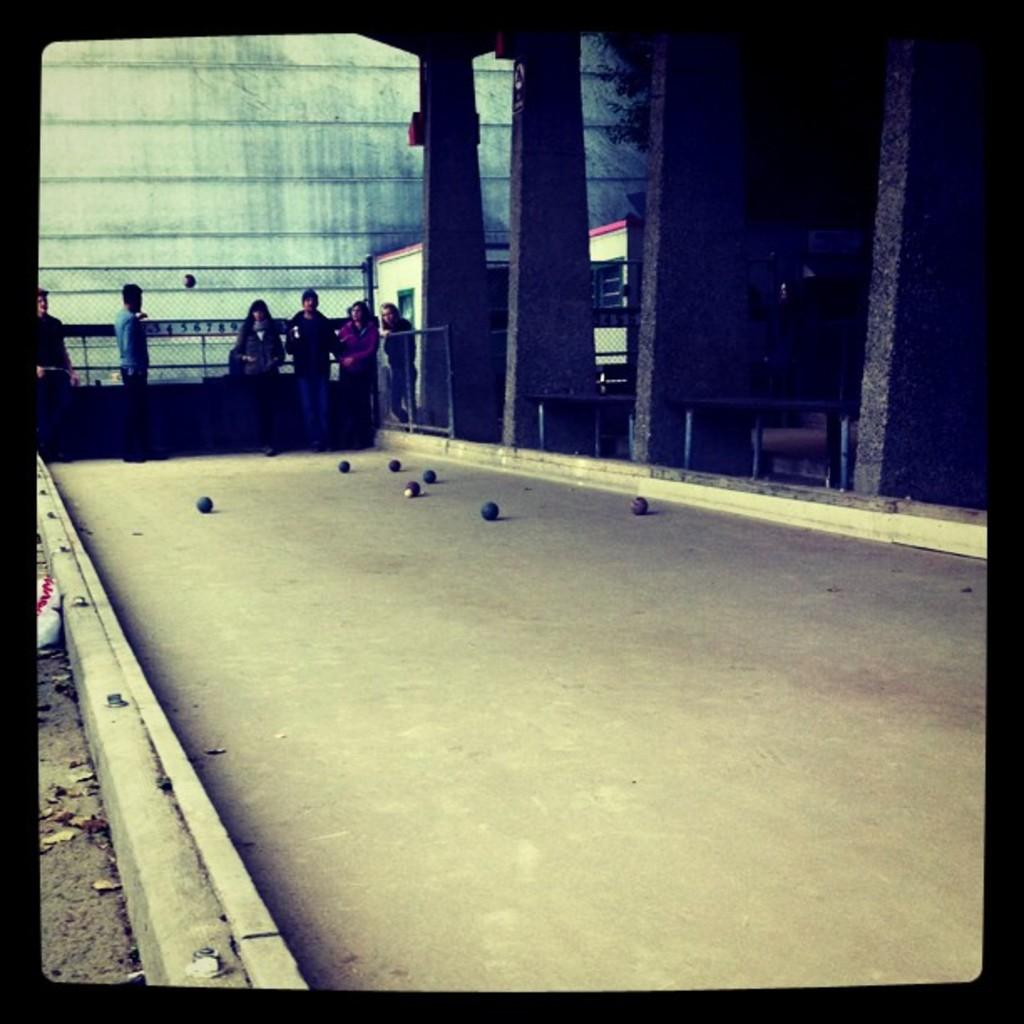What can be seen in the image involving people? There are people standing in the image. What objects are in front of the people? There are balls in front of the people. What architectural features are visible in the image? There are pillars, buildings, a fence, and a wall visible in the image. What type of net can be seen in the image? There is no net present in the image. Can you tell me the year this image was taken? The provided facts do not include any information about the year the image was taken. 